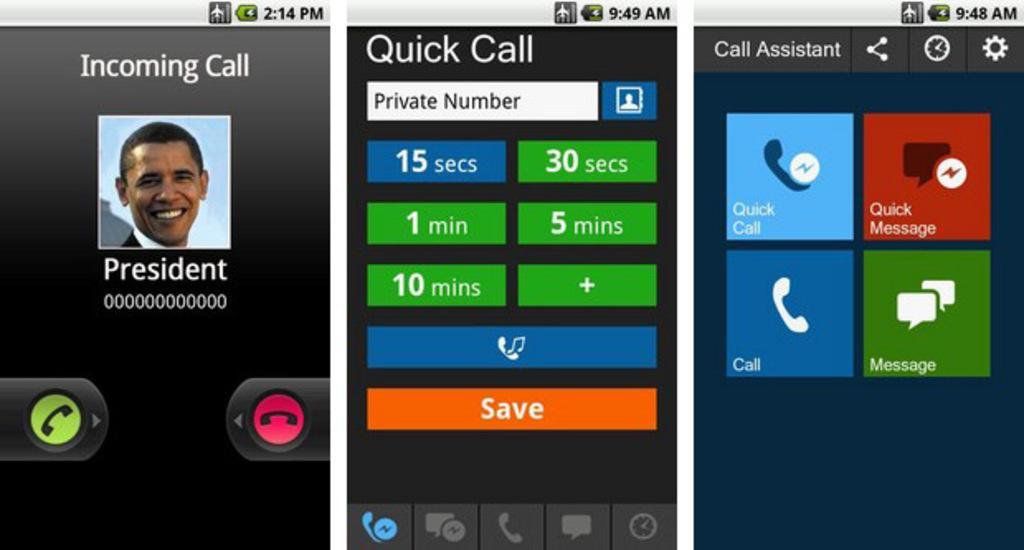Could you give a brief overview of what you see in this image? In this picture we can see a person and a call logo on the left side. In another picture we can see a time in seconds. There are few logos such as messenger. We can see four logos. These are message logs on the right side. On top, we can see a plane mode and a time. 